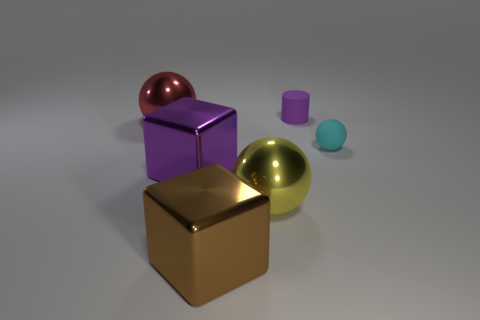Add 1 brown balls. How many objects exist? 7 Subtract all cylinders. How many objects are left? 5 Subtract all tiny purple matte cylinders. Subtract all cyan metallic cylinders. How many objects are left? 5 Add 3 large purple cubes. How many large purple cubes are left? 4 Add 3 shiny cubes. How many shiny cubes exist? 5 Subtract 1 brown cubes. How many objects are left? 5 